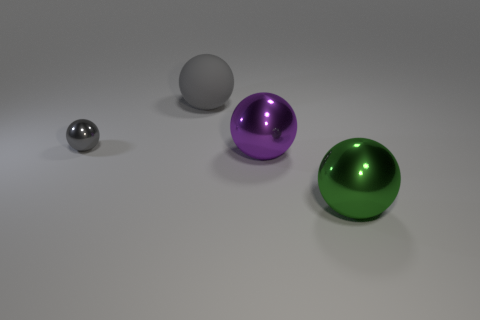Is the material of the big gray thing the same as the purple ball?
Make the answer very short. No. There is a metal thing that is the same color as the rubber ball; what size is it?
Provide a succinct answer. Small. Do the tiny metal ball and the large rubber object have the same color?
Keep it short and to the point. Yes. What shape is the small thing that is the same color as the large rubber ball?
Provide a succinct answer. Sphere. The other matte object that is the same shape as the tiny gray thing is what color?
Give a very brief answer. Gray. What number of objects are either large cyan shiny things or rubber spheres?
Your answer should be compact. 1. There is a object on the left side of the matte object; what is its shape?
Offer a terse response. Sphere. Is the number of green things on the right side of the large gray sphere the same as the number of metallic things that are to the left of the small metal object?
Make the answer very short. No. What number of objects are either big matte spheres or big balls that are in front of the rubber sphere?
Offer a terse response. 3. The object that is behind the purple shiny sphere and in front of the large matte thing has what shape?
Offer a terse response. Sphere. 